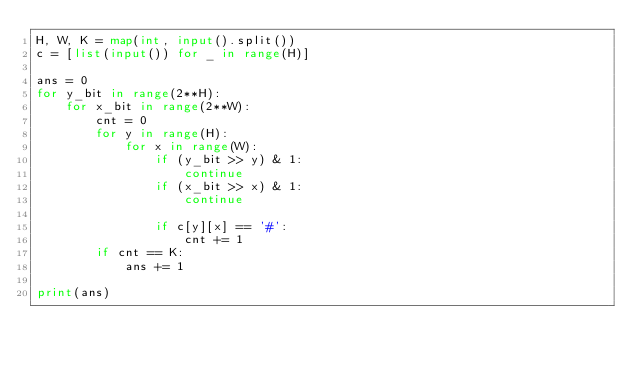Convert code to text. <code><loc_0><loc_0><loc_500><loc_500><_Python_>H, W, K = map(int, input().split())
c = [list(input()) for _ in range(H)]

ans = 0
for y_bit in range(2**H):
    for x_bit in range(2**W):
        cnt = 0
        for y in range(H):
            for x in range(W):
                if (y_bit >> y) & 1:
                    continue
                if (x_bit >> x) & 1:
                    continue

                if c[y][x] == '#':
                    cnt += 1
        if cnt == K:
            ans += 1

print(ans)</code> 